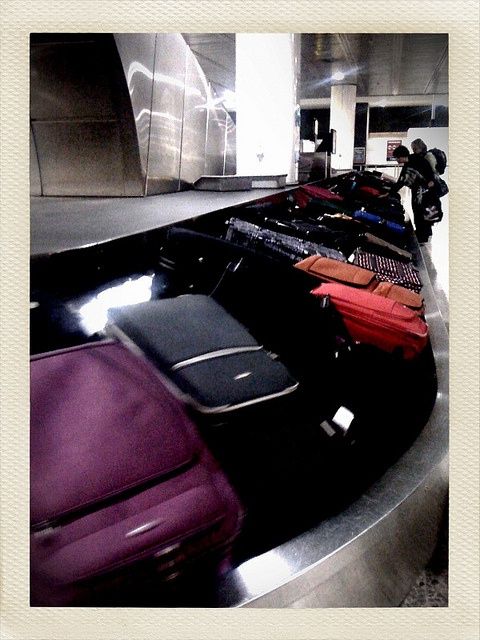Describe the objects in this image and their specific colors. I can see suitcase in lightgray, purple, and black tones, suitcase in lightgray, black, and gray tones, suitcase in lightgray, black, gray, and darkgray tones, suitcase in lightgray, maroon, salmon, black, and brown tones, and people in lightgray, black, gray, white, and darkgray tones in this image. 